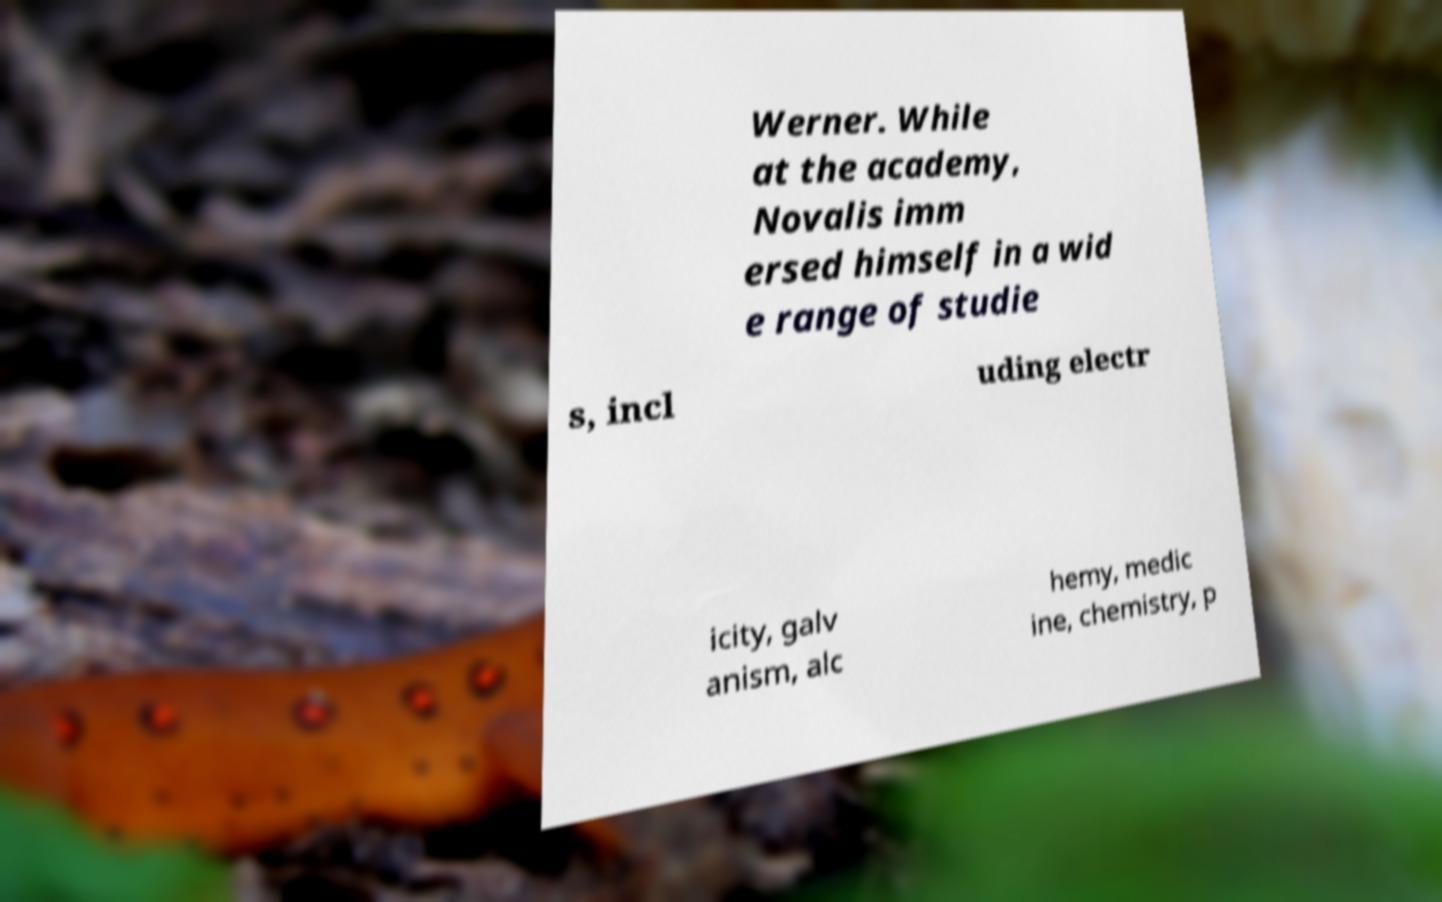Can you read and provide the text displayed in the image?This photo seems to have some interesting text. Can you extract and type it out for me? Werner. While at the academy, Novalis imm ersed himself in a wid e range of studie s, incl uding electr icity, galv anism, alc hemy, medic ine, chemistry, p 